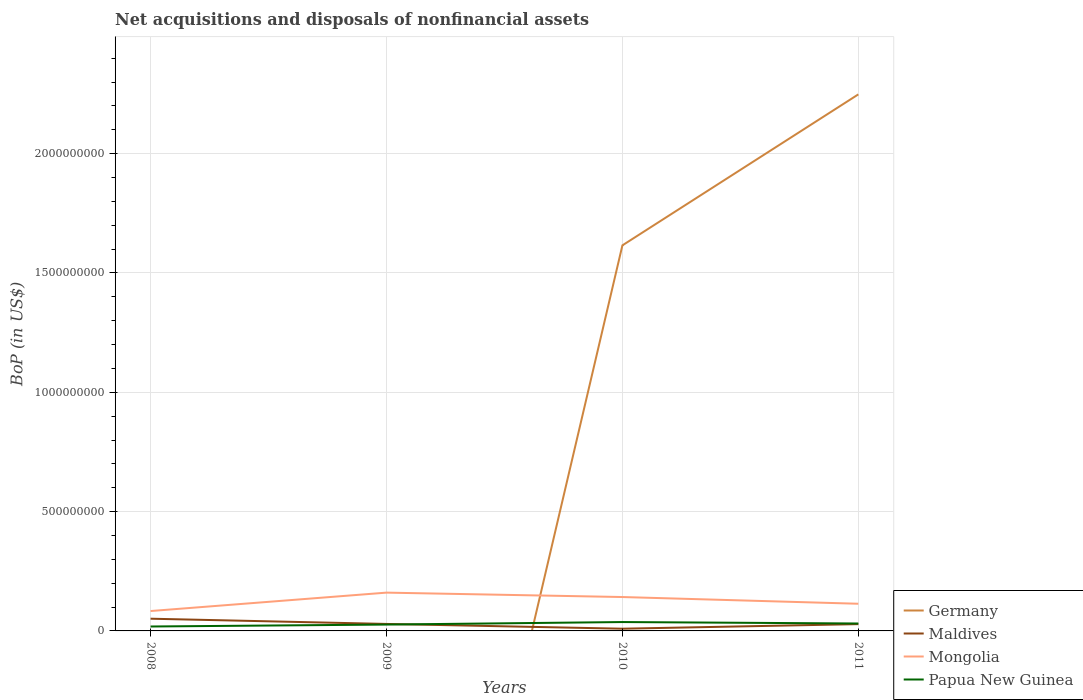How many different coloured lines are there?
Give a very brief answer. 4. Does the line corresponding to Germany intersect with the line corresponding to Mongolia?
Keep it short and to the point. Yes. Across all years, what is the maximum Balance of Payments in Mongolia?
Ensure brevity in your answer.  8.33e+07. What is the total Balance of Payments in Maldives in the graph?
Your response must be concise. -1.92e+07. What is the difference between the highest and the second highest Balance of Payments in Germany?
Offer a terse response. 2.25e+09. Is the Balance of Payments in Mongolia strictly greater than the Balance of Payments in Maldives over the years?
Ensure brevity in your answer.  No. How many years are there in the graph?
Provide a succinct answer. 4. What is the difference between two consecutive major ticks on the Y-axis?
Provide a succinct answer. 5.00e+08. Does the graph contain any zero values?
Offer a very short reply. Yes. Does the graph contain grids?
Provide a short and direct response. Yes. How many legend labels are there?
Make the answer very short. 4. What is the title of the graph?
Your answer should be very brief. Net acquisitions and disposals of nonfinancial assets. What is the label or title of the X-axis?
Your answer should be very brief. Years. What is the label or title of the Y-axis?
Your answer should be compact. BoP (in US$). What is the BoP (in US$) in Maldives in 2008?
Ensure brevity in your answer.  5.12e+07. What is the BoP (in US$) of Mongolia in 2008?
Offer a very short reply. 8.33e+07. What is the BoP (in US$) of Papua New Guinea in 2008?
Your answer should be compact. 1.86e+07. What is the BoP (in US$) of Maldives in 2009?
Provide a succinct answer. 2.93e+07. What is the BoP (in US$) of Mongolia in 2009?
Make the answer very short. 1.60e+08. What is the BoP (in US$) of Papua New Guinea in 2009?
Provide a succinct answer. 2.67e+07. What is the BoP (in US$) of Germany in 2010?
Your answer should be compact. 1.62e+09. What is the BoP (in US$) of Maldives in 2010?
Keep it short and to the point. 9.30e+06. What is the BoP (in US$) in Mongolia in 2010?
Offer a very short reply. 1.42e+08. What is the BoP (in US$) of Papua New Guinea in 2010?
Your answer should be compact. 3.72e+07. What is the BoP (in US$) in Germany in 2011?
Provide a succinct answer. 2.25e+09. What is the BoP (in US$) of Maldives in 2011?
Give a very brief answer. 2.85e+07. What is the BoP (in US$) in Mongolia in 2011?
Provide a short and direct response. 1.14e+08. What is the BoP (in US$) of Papua New Guinea in 2011?
Your answer should be very brief. 3.11e+07. Across all years, what is the maximum BoP (in US$) in Germany?
Your answer should be compact. 2.25e+09. Across all years, what is the maximum BoP (in US$) of Maldives?
Offer a terse response. 5.12e+07. Across all years, what is the maximum BoP (in US$) in Mongolia?
Ensure brevity in your answer.  1.60e+08. Across all years, what is the maximum BoP (in US$) in Papua New Guinea?
Offer a terse response. 3.72e+07. Across all years, what is the minimum BoP (in US$) of Maldives?
Offer a very short reply. 9.30e+06. Across all years, what is the minimum BoP (in US$) of Mongolia?
Offer a very short reply. 8.33e+07. Across all years, what is the minimum BoP (in US$) in Papua New Guinea?
Offer a very short reply. 1.86e+07. What is the total BoP (in US$) in Germany in the graph?
Offer a terse response. 3.86e+09. What is the total BoP (in US$) in Maldives in the graph?
Your answer should be compact. 1.18e+08. What is the total BoP (in US$) in Mongolia in the graph?
Your answer should be compact. 5.00e+08. What is the total BoP (in US$) in Papua New Guinea in the graph?
Offer a terse response. 1.14e+08. What is the difference between the BoP (in US$) of Maldives in 2008 and that in 2009?
Make the answer very short. 2.19e+07. What is the difference between the BoP (in US$) of Mongolia in 2008 and that in 2009?
Provide a short and direct response. -7.72e+07. What is the difference between the BoP (in US$) in Papua New Guinea in 2008 and that in 2009?
Give a very brief answer. -8.12e+06. What is the difference between the BoP (in US$) in Maldives in 2008 and that in 2010?
Ensure brevity in your answer.  4.19e+07. What is the difference between the BoP (in US$) in Mongolia in 2008 and that in 2010?
Offer a terse response. -5.87e+07. What is the difference between the BoP (in US$) in Papua New Guinea in 2008 and that in 2010?
Offer a very short reply. -1.86e+07. What is the difference between the BoP (in US$) in Maldives in 2008 and that in 2011?
Your response must be concise. 2.27e+07. What is the difference between the BoP (in US$) of Mongolia in 2008 and that in 2011?
Give a very brief answer. -3.05e+07. What is the difference between the BoP (in US$) of Papua New Guinea in 2008 and that in 2011?
Your answer should be compact. -1.26e+07. What is the difference between the BoP (in US$) in Maldives in 2009 and that in 2010?
Provide a succinct answer. 2.00e+07. What is the difference between the BoP (in US$) of Mongolia in 2009 and that in 2010?
Your response must be concise. 1.85e+07. What is the difference between the BoP (in US$) of Papua New Guinea in 2009 and that in 2010?
Your answer should be very brief. -1.05e+07. What is the difference between the BoP (in US$) in Maldives in 2009 and that in 2011?
Offer a very short reply. 8.41e+05. What is the difference between the BoP (in US$) of Mongolia in 2009 and that in 2011?
Keep it short and to the point. 4.66e+07. What is the difference between the BoP (in US$) of Papua New Guinea in 2009 and that in 2011?
Keep it short and to the point. -4.45e+06. What is the difference between the BoP (in US$) in Germany in 2010 and that in 2011?
Offer a very short reply. -6.33e+08. What is the difference between the BoP (in US$) of Maldives in 2010 and that in 2011?
Your answer should be very brief. -1.92e+07. What is the difference between the BoP (in US$) in Mongolia in 2010 and that in 2011?
Provide a succinct answer. 2.81e+07. What is the difference between the BoP (in US$) of Papua New Guinea in 2010 and that in 2011?
Offer a terse response. 6.05e+06. What is the difference between the BoP (in US$) in Maldives in 2008 and the BoP (in US$) in Mongolia in 2009?
Your answer should be very brief. -1.09e+08. What is the difference between the BoP (in US$) of Maldives in 2008 and the BoP (in US$) of Papua New Guinea in 2009?
Keep it short and to the point. 2.45e+07. What is the difference between the BoP (in US$) of Mongolia in 2008 and the BoP (in US$) of Papua New Guinea in 2009?
Your answer should be compact. 5.66e+07. What is the difference between the BoP (in US$) of Maldives in 2008 and the BoP (in US$) of Mongolia in 2010?
Keep it short and to the point. -9.08e+07. What is the difference between the BoP (in US$) in Maldives in 2008 and the BoP (in US$) in Papua New Guinea in 2010?
Provide a short and direct response. 1.40e+07. What is the difference between the BoP (in US$) in Mongolia in 2008 and the BoP (in US$) in Papua New Guinea in 2010?
Provide a succinct answer. 4.61e+07. What is the difference between the BoP (in US$) in Maldives in 2008 and the BoP (in US$) in Mongolia in 2011?
Give a very brief answer. -6.27e+07. What is the difference between the BoP (in US$) in Maldives in 2008 and the BoP (in US$) in Papua New Guinea in 2011?
Ensure brevity in your answer.  2.01e+07. What is the difference between the BoP (in US$) of Mongolia in 2008 and the BoP (in US$) of Papua New Guinea in 2011?
Provide a succinct answer. 5.22e+07. What is the difference between the BoP (in US$) in Maldives in 2009 and the BoP (in US$) in Mongolia in 2010?
Provide a short and direct response. -1.13e+08. What is the difference between the BoP (in US$) in Maldives in 2009 and the BoP (in US$) in Papua New Guinea in 2010?
Provide a short and direct response. -7.88e+06. What is the difference between the BoP (in US$) of Mongolia in 2009 and the BoP (in US$) of Papua New Guinea in 2010?
Give a very brief answer. 1.23e+08. What is the difference between the BoP (in US$) of Maldives in 2009 and the BoP (in US$) of Mongolia in 2011?
Your answer should be compact. -8.46e+07. What is the difference between the BoP (in US$) of Maldives in 2009 and the BoP (in US$) of Papua New Guinea in 2011?
Give a very brief answer. -1.83e+06. What is the difference between the BoP (in US$) in Mongolia in 2009 and the BoP (in US$) in Papua New Guinea in 2011?
Offer a terse response. 1.29e+08. What is the difference between the BoP (in US$) of Germany in 2010 and the BoP (in US$) of Maldives in 2011?
Give a very brief answer. 1.59e+09. What is the difference between the BoP (in US$) in Germany in 2010 and the BoP (in US$) in Mongolia in 2011?
Offer a terse response. 1.50e+09. What is the difference between the BoP (in US$) of Germany in 2010 and the BoP (in US$) of Papua New Guinea in 2011?
Your answer should be very brief. 1.58e+09. What is the difference between the BoP (in US$) in Maldives in 2010 and the BoP (in US$) in Mongolia in 2011?
Provide a short and direct response. -1.05e+08. What is the difference between the BoP (in US$) in Maldives in 2010 and the BoP (in US$) in Papua New Guinea in 2011?
Keep it short and to the point. -2.18e+07. What is the difference between the BoP (in US$) in Mongolia in 2010 and the BoP (in US$) in Papua New Guinea in 2011?
Give a very brief answer. 1.11e+08. What is the average BoP (in US$) of Germany per year?
Give a very brief answer. 9.66e+08. What is the average BoP (in US$) of Maldives per year?
Your answer should be compact. 2.96e+07. What is the average BoP (in US$) in Mongolia per year?
Keep it short and to the point. 1.25e+08. What is the average BoP (in US$) of Papua New Guinea per year?
Provide a short and direct response. 2.84e+07. In the year 2008, what is the difference between the BoP (in US$) of Maldives and BoP (in US$) of Mongolia?
Provide a short and direct response. -3.21e+07. In the year 2008, what is the difference between the BoP (in US$) of Maldives and BoP (in US$) of Papua New Guinea?
Your response must be concise. 3.26e+07. In the year 2008, what is the difference between the BoP (in US$) in Mongolia and BoP (in US$) in Papua New Guinea?
Give a very brief answer. 6.48e+07. In the year 2009, what is the difference between the BoP (in US$) of Maldives and BoP (in US$) of Mongolia?
Provide a short and direct response. -1.31e+08. In the year 2009, what is the difference between the BoP (in US$) in Maldives and BoP (in US$) in Papua New Guinea?
Your response must be concise. 2.62e+06. In the year 2009, what is the difference between the BoP (in US$) in Mongolia and BoP (in US$) in Papua New Guinea?
Offer a very short reply. 1.34e+08. In the year 2010, what is the difference between the BoP (in US$) in Germany and BoP (in US$) in Maldives?
Give a very brief answer. 1.61e+09. In the year 2010, what is the difference between the BoP (in US$) in Germany and BoP (in US$) in Mongolia?
Your response must be concise. 1.47e+09. In the year 2010, what is the difference between the BoP (in US$) in Germany and BoP (in US$) in Papua New Guinea?
Your answer should be compact. 1.58e+09. In the year 2010, what is the difference between the BoP (in US$) of Maldives and BoP (in US$) of Mongolia?
Offer a very short reply. -1.33e+08. In the year 2010, what is the difference between the BoP (in US$) of Maldives and BoP (in US$) of Papua New Guinea?
Provide a short and direct response. -2.79e+07. In the year 2010, what is the difference between the BoP (in US$) in Mongolia and BoP (in US$) in Papua New Guinea?
Your answer should be very brief. 1.05e+08. In the year 2011, what is the difference between the BoP (in US$) of Germany and BoP (in US$) of Maldives?
Ensure brevity in your answer.  2.22e+09. In the year 2011, what is the difference between the BoP (in US$) of Germany and BoP (in US$) of Mongolia?
Offer a very short reply. 2.13e+09. In the year 2011, what is the difference between the BoP (in US$) of Germany and BoP (in US$) of Papua New Guinea?
Make the answer very short. 2.22e+09. In the year 2011, what is the difference between the BoP (in US$) in Maldives and BoP (in US$) in Mongolia?
Keep it short and to the point. -8.54e+07. In the year 2011, what is the difference between the BoP (in US$) of Maldives and BoP (in US$) of Papua New Guinea?
Offer a terse response. -2.67e+06. In the year 2011, what is the difference between the BoP (in US$) in Mongolia and BoP (in US$) in Papua New Guinea?
Your answer should be compact. 8.27e+07. What is the ratio of the BoP (in US$) in Maldives in 2008 to that in 2009?
Offer a very short reply. 1.75. What is the ratio of the BoP (in US$) of Mongolia in 2008 to that in 2009?
Your response must be concise. 0.52. What is the ratio of the BoP (in US$) in Papua New Guinea in 2008 to that in 2009?
Keep it short and to the point. 0.7. What is the ratio of the BoP (in US$) in Maldives in 2008 to that in 2010?
Offer a very short reply. 5.5. What is the ratio of the BoP (in US$) in Mongolia in 2008 to that in 2010?
Your answer should be compact. 0.59. What is the ratio of the BoP (in US$) of Papua New Guinea in 2008 to that in 2010?
Make the answer very short. 0.5. What is the ratio of the BoP (in US$) of Maldives in 2008 to that in 2011?
Your answer should be very brief. 1.8. What is the ratio of the BoP (in US$) in Mongolia in 2008 to that in 2011?
Offer a terse response. 0.73. What is the ratio of the BoP (in US$) in Papua New Guinea in 2008 to that in 2011?
Keep it short and to the point. 0.6. What is the ratio of the BoP (in US$) of Maldives in 2009 to that in 2010?
Offer a terse response. 3.15. What is the ratio of the BoP (in US$) of Mongolia in 2009 to that in 2010?
Your answer should be compact. 1.13. What is the ratio of the BoP (in US$) of Papua New Guinea in 2009 to that in 2010?
Keep it short and to the point. 0.72. What is the ratio of the BoP (in US$) in Maldives in 2009 to that in 2011?
Your answer should be very brief. 1.03. What is the ratio of the BoP (in US$) in Mongolia in 2009 to that in 2011?
Your answer should be compact. 1.41. What is the ratio of the BoP (in US$) of Germany in 2010 to that in 2011?
Give a very brief answer. 0.72. What is the ratio of the BoP (in US$) of Maldives in 2010 to that in 2011?
Provide a succinct answer. 0.33. What is the ratio of the BoP (in US$) in Mongolia in 2010 to that in 2011?
Your answer should be very brief. 1.25. What is the ratio of the BoP (in US$) in Papua New Guinea in 2010 to that in 2011?
Your answer should be very brief. 1.19. What is the difference between the highest and the second highest BoP (in US$) in Maldives?
Keep it short and to the point. 2.19e+07. What is the difference between the highest and the second highest BoP (in US$) of Mongolia?
Your answer should be very brief. 1.85e+07. What is the difference between the highest and the second highest BoP (in US$) of Papua New Guinea?
Make the answer very short. 6.05e+06. What is the difference between the highest and the lowest BoP (in US$) of Germany?
Keep it short and to the point. 2.25e+09. What is the difference between the highest and the lowest BoP (in US$) of Maldives?
Offer a very short reply. 4.19e+07. What is the difference between the highest and the lowest BoP (in US$) in Mongolia?
Make the answer very short. 7.72e+07. What is the difference between the highest and the lowest BoP (in US$) in Papua New Guinea?
Your response must be concise. 1.86e+07. 